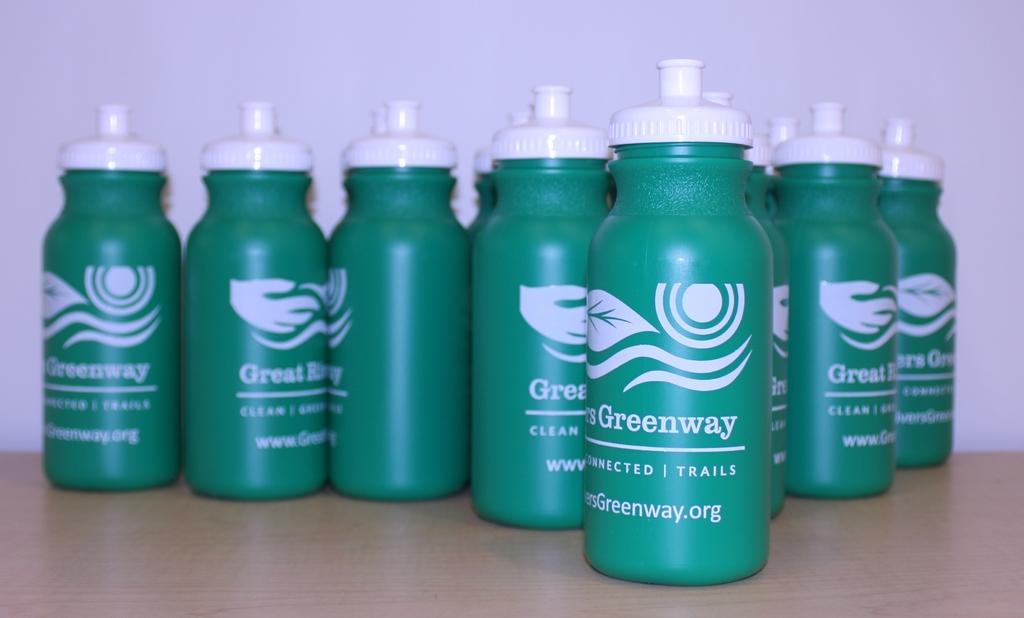What is the web address?
Offer a terse response. Www.greenway.org. What is the brand featured on these bottles?
Your answer should be very brief. Greenway. 